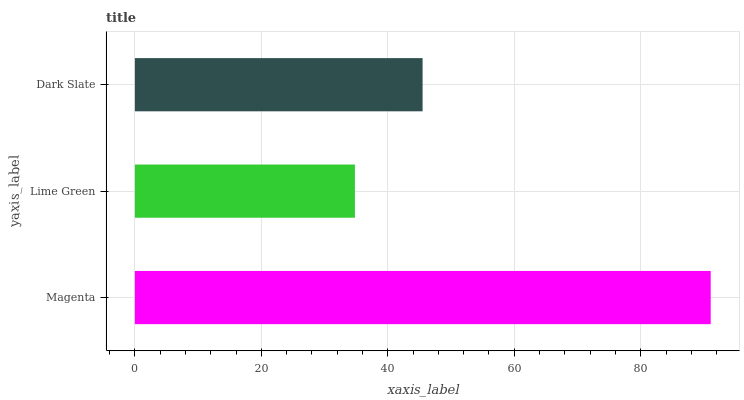Is Lime Green the minimum?
Answer yes or no. Yes. Is Magenta the maximum?
Answer yes or no. Yes. Is Dark Slate the minimum?
Answer yes or no. No. Is Dark Slate the maximum?
Answer yes or no. No. Is Dark Slate greater than Lime Green?
Answer yes or no. Yes. Is Lime Green less than Dark Slate?
Answer yes or no. Yes. Is Lime Green greater than Dark Slate?
Answer yes or no. No. Is Dark Slate less than Lime Green?
Answer yes or no. No. Is Dark Slate the high median?
Answer yes or no. Yes. Is Dark Slate the low median?
Answer yes or no. Yes. Is Magenta the high median?
Answer yes or no. No. Is Lime Green the low median?
Answer yes or no. No. 